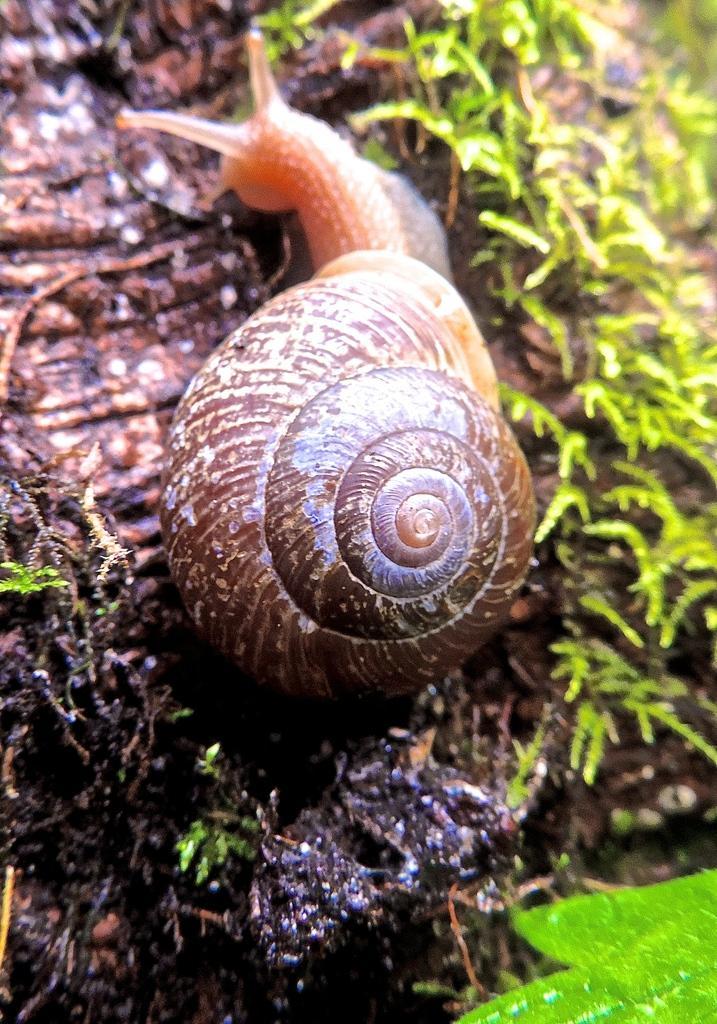How would you summarize this image in a sentence or two? In this image there is a snail on a land and there are small plants. 